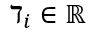Convert formula to latex. <formula><loc_0><loc_0><loc_500><loc_500>\daleth _ { i } \in \mathbb { R }</formula> 